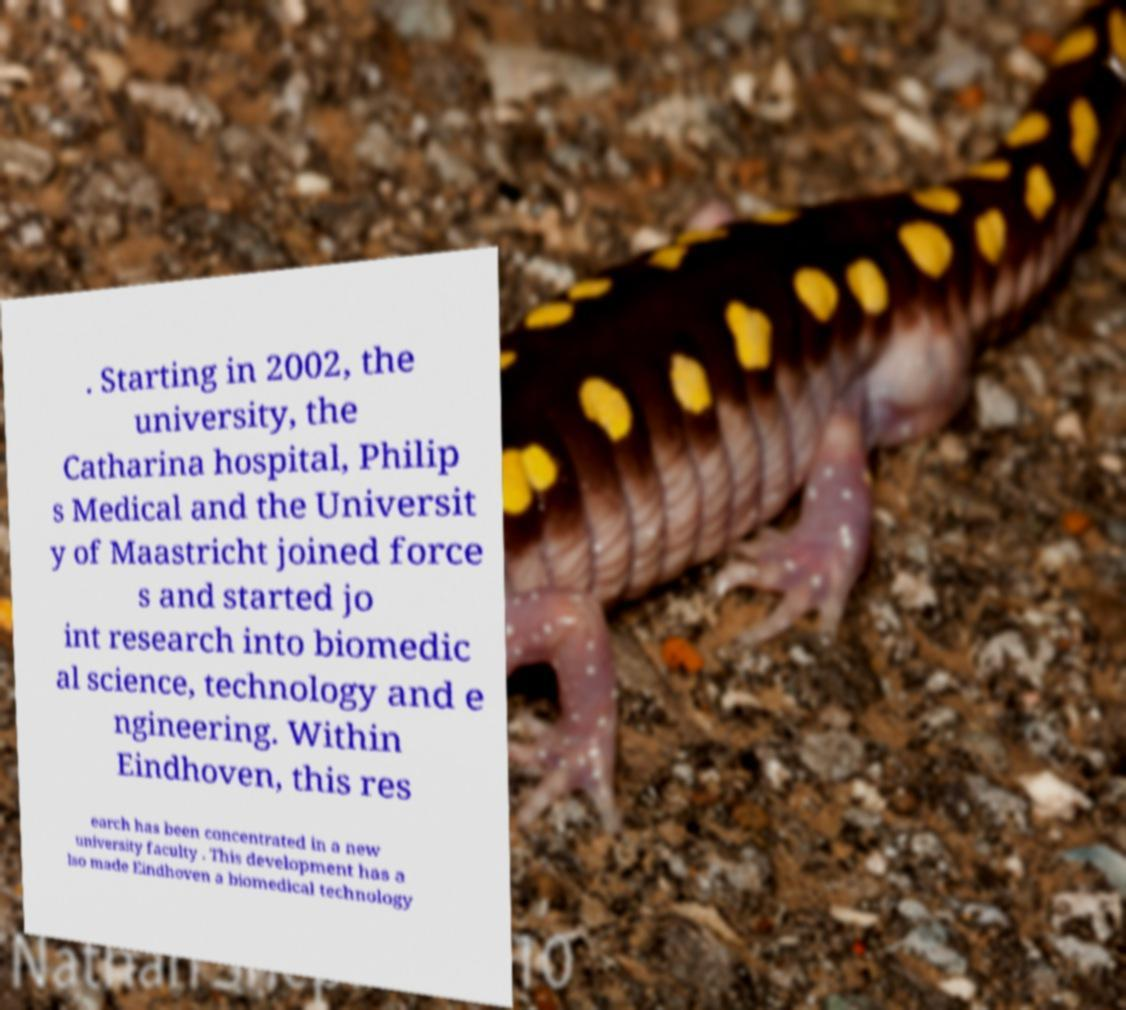For documentation purposes, I need the text within this image transcribed. Could you provide that? . Starting in 2002, the university, the Catharina hospital, Philip s Medical and the Universit y of Maastricht joined force s and started jo int research into biomedic al science, technology and e ngineering. Within Eindhoven, this res earch has been concentrated in a new university faculty . This development has a lso made Eindhoven a biomedical technology 